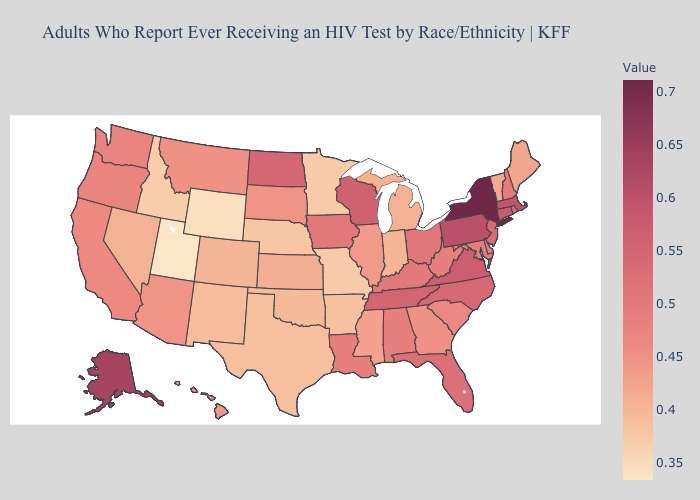Does New Mexico have the highest value in the USA?
Give a very brief answer. No. Does New York have the highest value in the Northeast?
Write a very short answer. Yes. Which states have the lowest value in the USA?
Keep it brief. Utah. 